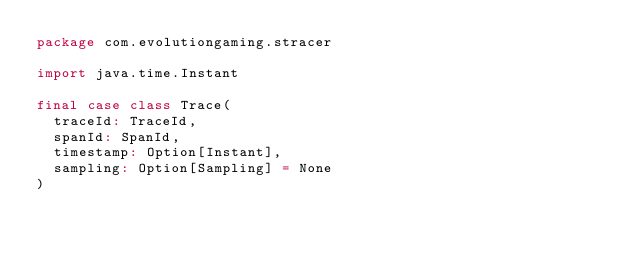Convert code to text. <code><loc_0><loc_0><loc_500><loc_500><_Scala_>package com.evolutiongaming.stracer

import java.time.Instant

final case class Trace(
  traceId: TraceId,
  spanId: SpanId,
  timestamp: Option[Instant],
  sampling: Option[Sampling] = None
)
</code> 